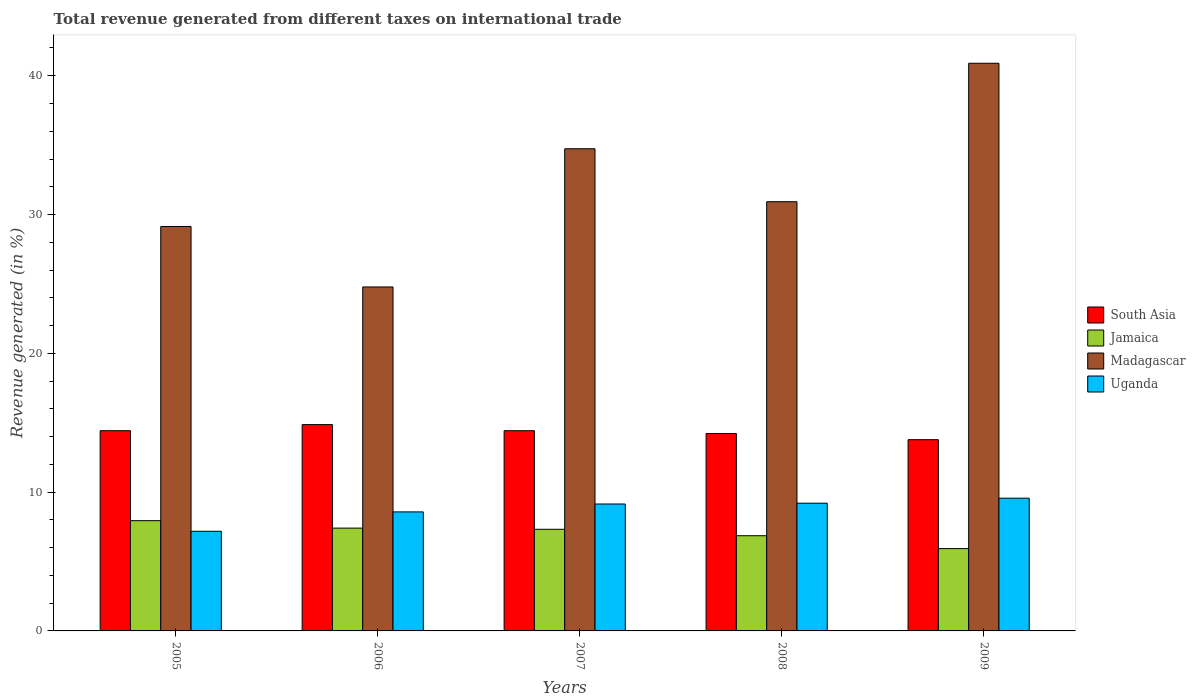How many different coloured bars are there?
Your answer should be very brief. 4. How many groups of bars are there?
Make the answer very short. 5. Are the number of bars on each tick of the X-axis equal?
Your answer should be compact. Yes. How many bars are there on the 2nd tick from the left?
Your response must be concise. 4. How many bars are there on the 4th tick from the right?
Your response must be concise. 4. What is the total revenue generated in Uganda in 2006?
Give a very brief answer. 8.58. Across all years, what is the maximum total revenue generated in South Asia?
Offer a very short reply. 14.86. Across all years, what is the minimum total revenue generated in Uganda?
Keep it short and to the point. 7.18. In which year was the total revenue generated in Uganda minimum?
Offer a terse response. 2005. What is the total total revenue generated in Madagascar in the graph?
Keep it short and to the point. 160.48. What is the difference between the total revenue generated in Madagascar in 2006 and that in 2008?
Your answer should be compact. -6.14. What is the difference between the total revenue generated in Jamaica in 2005 and the total revenue generated in Uganda in 2006?
Your answer should be very brief. -0.63. What is the average total revenue generated in Madagascar per year?
Offer a very short reply. 32.1. In the year 2008, what is the difference between the total revenue generated in Jamaica and total revenue generated in Uganda?
Make the answer very short. -2.34. In how many years, is the total revenue generated in Jamaica greater than 24 %?
Provide a short and direct response. 0. What is the ratio of the total revenue generated in Uganda in 2005 to that in 2006?
Make the answer very short. 0.84. Is the total revenue generated in Jamaica in 2005 less than that in 2009?
Provide a short and direct response. No. Is the difference between the total revenue generated in Jamaica in 2005 and 2008 greater than the difference between the total revenue generated in Uganda in 2005 and 2008?
Your answer should be very brief. Yes. What is the difference between the highest and the second highest total revenue generated in Uganda?
Give a very brief answer. 0.36. What is the difference between the highest and the lowest total revenue generated in South Asia?
Keep it short and to the point. 1.09. Is it the case that in every year, the sum of the total revenue generated in Madagascar and total revenue generated in Jamaica is greater than the sum of total revenue generated in Uganda and total revenue generated in South Asia?
Ensure brevity in your answer.  Yes. What does the 1st bar from the left in 2007 represents?
Provide a short and direct response. South Asia. What does the 2nd bar from the right in 2008 represents?
Give a very brief answer. Madagascar. Is it the case that in every year, the sum of the total revenue generated in South Asia and total revenue generated in Jamaica is greater than the total revenue generated in Madagascar?
Your answer should be very brief. No. Are the values on the major ticks of Y-axis written in scientific E-notation?
Make the answer very short. No. Does the graph contain any zero values?
Give a very brief answer. No. Does the graph contain grids?
Provide a short and direct response. No. How are the legend labels stacked?
Keep it short and to the point. Vertical. What is the title of the graph?
Ensure brevity in your answer.  Total revenue generated from different taxes on international trade. What is the label or title of the X-axis?
Keep it short and to the point. Years. What is the label or title of the Y-axis?
Offer a terse response. Revenue generated (in %). What is the Revenue generated (in %) in South Asia in 2005?
Give a very brief answer. 14.43. What is the Revenue generated (in %) in Jamaica in 2005?
Offer a very short reply. 7.94. What is the Revenue generated (in %) of Madagascar in 2005?
Make the answer very short. 29.14. What is the Revenue generated (in %) in Uganda in 2005?
Give a very brief answer. 7.18. What is the Revenue generated (in %) in South Asia in 2006?
Provide a short and direct response. 14.86. What is the Revenue generated (in %) in Jamaica in 2006?
Give a very brief answer. 7.41. What is the Revenue generated (in %) in Madagascar in 2006?
Keep it short and to the point. 24.78. What is the Revenue generated (in %) of Uganda in 2006?
Provide a short and direct response. 8.58. What is the Revenue generated (in %) of South Asia in 2007?
Provide a succinct answer. 14.42. What is the Revenue generated (in %) of Jamaica in 2007?
Provide a short and direct response. 7.32. What is the Revenue generated (in %) of Madagascar in 2007?
Give a very brief answer. 34.74. What is the Revenue generated (in %) in Uganda in 2007?
Keep it short and to the point. 9.14. What is the Revenue generated (in %) of South Asia in 2008?
Offer a very short reply. 14.22. What is the Revenue generated (in %) in Jamaica in 2008?
Provide a short and direct response. 6.86. What is the Revenue generated (in %) of Madagascar in 2008?
Make the answer very short. 30.92. What is the Revenue generated (in %) in Uganda in 2008?
Offer a very short reply. 9.2. What is the Revenue generated (in %) of South Asia in 2009?
Your answer should be very brief. 13.78. What is the Revenue generated (in %) of Jamaica in 2009?
Offer a very short reply. 5.93. What is the Revenue generated (in %) of Madagascar in 2009?
Provide a succinct answer. 40.9. What is the Revenue generated (in %) of Uganda in 2009?
Your answer should be very brief. 9.56. Across all years, what is the maximum Revenue generated (in %) in South Asia?
Make the answer very short. 14.86. Across all years, what is the maximum Revenue generated (in %) of Jamaica?
Give a very brief answer. 7.94. Across all years, what is the maximum Revenue generated (in %) of Madagascar?
Offer a terse response. 40.9. Across all years, what is the maximum Revenue generated (in %) of Uganda?
Provide a short and direct response. 9.56. Across all years, what is the minimum Revenue generated (in %) in South Asia?
Ensure brevity in your answer.  13.78. Across all years, what is the minimum Revenue generated (in %) of Jamaica?
Provide a short and direct response. 5.93. Across all years, what is the minimum Revenue generated (in %) in Madagascar?
Your answer should be very brief. 24.78. Across all years, what is the minimum Revenue generated (in %) of Uganda?
Your response must be concise. 7.18. What is the total Revenue generated (in %) of South Asia in the graph?
Your answer should be very brief. 71.72. What is the total Revenue generated (in %) in Jamaica in the graph?
Offer a very short reply. 35.46. What is the total Revenue generated (in %) of Madagascar in the graph?
Provide a succinct answer. 160.48. What is the total Revenue generated (in %) of Uganda in the graph?
Keep it short and to the point. 43.67. What is the difference between the Revenue generated (in %) in South Asia in 2005 and that in 2006?
Offer a very short reply. -0.44. What is the difference between the Revenue generated (in %) of Jamaica in 2005 and that in 2006?
Make the answer very short. 0.54. What is the difference between the Revenue generated (in %) of Madagascar in 2005 and that in 2006?
Offer a very short reply. 4.36. What is the difference between the Revenue generated (in %) in Uganda in 2005 and that in 2006?
Your response must be concise. -1.39. What is the difference between the Revenue generated (in %) in South Asia in 2005 and that in 2007?
Offer a terse response. 0. What is the difference between the Revenue generated (in %) of Jamaica in 2005 and that in 2007?
Your answer should be compact. 0.62. What is the difference between the Revenue generated (in %) in Madagascar in 2005 and that in 2007?
Your response must be concise. -5.6. What is the difference between the Revenue generated (in %) of Uganda in 2005 and that in 2007?
Make the answer very short. -1.96. What is the difference between the Revenue generated (in %) of South Asia in 2005 and that in 2008?
Offer a terse response. 0.2. What is the difference between the Revenue generated (in %) in Jamaica in 2005 and that in 2008?
Provide a short and direct response. 1.09. What is the difference between the Revenue generated (in %) of Madagascar in 2005 and that in 2008?
Your answer should be very brief. -1.79. What is the difference between the Revenue generated (in %) in Uganda in 2005 and that in 2008?
Your answer should be compact. -2.02. What is the difference between the Revenue generated (in %) of South Asia in 2005 and that in 2009?
Your response must be concise. 0.65. What is the difference between the Revenue generated (in %) of Jamaica in 2005 and that in 2009?
Your response must be concise. 2.01. What is the difference between the Revenue generated (in %) of Madagascar in 2005 and that in 2009?
Ensure brevity in your answer.  -11.76. What is the difference between the Revenue generated (in %) of Uganda in 2005 and that in 2009?
Provide a short and direct response. -2.38. What is the difference between the Revenue generated (in %) of South Asia in 2006 and that in 2007?
Offer a very short reply. 0.44. What is the difference between the Revenue generated (in %) of Jamaica in 2006 and that in 2007?
Ensure brevity in your answer.  0.08. What is the difference between the Revenue generated (in %) in Madagascar in 2006 and that in 2007?
Give a very brief answer. -9.96. What is the difference between the Revenue generated (in %) in Uganda in 2006 and that in 2007?
Provide a succinct answer. -0.57. What is the difference between the Revenue generated (in %) in South Asia in 2006 and that in 2008?
Keep it short and to the point. 0.64. What is the difference between the Revenue generated (in %) in Jamaica in 2006 and that in 2008?
Your answer should be compact. 0.55. What is the difference between the Revenue generated (in %) in Madagascar in 2006 and that in 2008?
Ensure brevity in your answer.  -6.14. What is the difference between the Revenue generated (in %) of Uganda in 2006 and that in 2008?
Offer a terse response. -0.63. What is the difference between the Revenue generated (in %) of South Asia in 2006 and that in 2009?
Make the answer very short. 1.09. What is the difference between the Revenue generated (in %) of Jamaica in 2006 and that in 2009?
Give a very brief answer. 1.48. What is the difference between the Revenue generated (in %) of Madagascar in 2006 and that in 2009?
Ensure brevity in your answer.  -16.12. What is the difference between the Revenue generated (in %) of Uganda in 2006 and that in 2009?
Offer a terse response. -0.99. What is the difference between the Revenue generated (in %) of South Asia in 2007 and that in 2008?
Provide a succinct answer. 0.2. What is the difference between the Revenue generated (in %) of Jamaica in 2007 and that in 2008?
Your answer should be compact. 0.46. What is the difference between the Revenue generated (in %) in Madagascar in 2007 and that in 2008?
Your response must be concise. 3.82. What is the difference between the Revenue generated (in %) of Uganda in 2007 and that in 2008?
Your answer should be very brief. -0.06. What is the difference between the Revenue generated (in %) in South Asia in 2007 and that in 2009?
Your answer should be compact. 0.65. What is the difference between the Revenue generated (in %) in Jamaica in 2007 and that in 2009?
Offer a terse response. 1.39. What is the difference between the Revenue generated (in %) in Madagascar in 2007 and that in 2009?
Keep it short and to the point. -6.16. What is the difference between the Revenue generated (in %) in Uganda in 2007 and that in 2009?
Your answer should be compact. -0.42. What is the difference between the Revenue generated (in %) in South Asia in 2008 and that in 2009?
Provide a short and direct response. 0.45. What is the difference between the Revenue generated (in %) in Jamaica in 2008 and that in 2009?
Provide a short and direct response. 0.93. What is the difference between the Revenue generated (in %) in Madagascar in 2008 and that in 2009?
Your response must be concise. -9.98. What is the difference between the Revenue generated (in %) of Uganda in 2008 and that in 2009?
Make the answer very short. -0.36. What is the difference between the Revenue generated (in %) in South Asia in 2005 and the Revenue generated (in %) in Jamaica in 2006?
Offer a very short reply. 7.02. What is the difference between the Revenue generated (in %) of South Asia in 2005 and the Revenue generated (in %) of Madagascar in 2006?
Give a very brief answer. -10.36. What is the difference between the Revenue generated (in %) of South Asia in 2005 and the Revenue generated (in %) of Uganda in 2006?
Keep it short and to the point. 5.85. What is the difference between the Revenue generated (in %) of Jamaica in 2005 and the Revenue generated (in %) of Madagascar in 2006?
Offer a very short reply. -16.84. What is the difference between the Revenue generated (in %) in Jamaica in 2005 and the Revenue generated (in %) in Uganda in 2006?
Ensure brevity in your answer.  -0.63. What is the difference between the Revenue generated (in %) in Madagascar in 2005 and the Revenue generated (in %) in Uganda in 2006?
Offer a very short reply. 20.56. What is the difference between the Revenue generated (in %) of South Asia in 2005 and the Revenue generated (in %) of Jamaica in 2007?
Ensure brevity in your answer.  7.1. What is the difference between the Revenue generated (in %) of South Asia in 2005 and the Revenue generated (in %) of Madagascar in 2007?
Your answer should be very brief. -20.31. What is the difference between the Revenue generated (in %) in South Asia in 2005 and the Revenue generated (in %) in Uganda in 2007?
Make the answer very short. 5.28. What is the difference between the Revenue generated (in %) of Jamaica in 2005 and the Revenue generated (in %) of Madagascar in 2007?
Ensure brevity in your answer.  -26.8. What is the difference between the Revenue generated (in %) of Jamaica in 2005 and the Revenue generated (in %) of Uganda in 2007?
Your response must be concise. -1.2. What is the difference between the Revenue generated (in %) of Madagascar in 2005 and the Revenue generated (in %) of Uganda in 2007?
Make the answer very short. 19.99. What is the difference between the Revenue generated (in %) of South Asia in 2005 and the Revenue generated (in %) of Jamaica in 2008?
Make the answer very short. 7.57. What is the difference between the Revenue generated (in %) of South Asia in 2005 and the Revenue generated (in %) of Madagascar in 2008?
Give a very brief answer. -16.5. What is the difference between the Revenue generated (in %) in South Asia in 2005 and the Revenue generated (in %) in Uganda in 2008?
Ensure brevity in your answer.  5.22. What is the difference between the Revenue generated (in %) of Jamaica in 2005 and the Revenue generated (in %) of Madagascar in 2008?
Offer a very short reply. -22.98. What is the difference between the Revenue generated (in %) of Jamaica in 2005 and the Revenue generated (in %) of Uganda in 2008?
Ensure brevity in your answer.  -1.26. What is the difference between the Revenue generated (in %) in Madagascar in 2005 and the Revenue generated (in %) in Uganda in 2008?
Ensure brevity in your answer.  19.94. What is the difference between the Revenue generated (in %) of South Asia in 2005 and the Revenue generated (in %) of Jamaica in 2009?
Ensure brevity in your answer.  8.49. What is the difference between the Revenue generated (in %) in South Asia in 2005 and the Revenue generated (in %) in Madagascar in 2009?
Your answer should be compact. -26.47. What is the difference between the Revenue generated (in %) of South Asia in 2005 and the Revenue generated (in %) of Uganda in 2009?
Your answer should be compact. 4.86. What is the difference between the Revenue generated (in %) in Jamaica in 2005 and the Revenue generated (in %) in Madagascar in 2009?
Provide a succinct answer. -32.96. What is the difference between the Revenue generated (in %) of Jamaica in 2005 and the Revenue generated (in %) of Uganda in 2009?
Give a very brief answer. -1.62. What is the difference between the Revenue generated (in %) of Madagascar in 2005 and the Revenue generated (in %) of Uganda in 2009?
Keep it short and to the point. 19.57. What is the difference between the Revenue generated (in %) of South Asia in 2006 and the Revenue generated (in %) of Jamaica in 2007?
Provide a succinct answer. 7.54. What is the difference between the Revenue generated (in %) of South Asia in 2006 and the Revenue generated (in %) of Madagascar in 2007?
Provide a short and direct response. -19.87. What is the difference between the Revenue generated (in %) of South Asia in 2006 and the Revenue generated (in %) of Uganda in 2007?
Your answer should be compact. 5.72. What is the difference between the Revenue generated (in %) in Jamaica in 2006 and the Revenue generated (in %) in Madagascar in 2007?
Make the answer very short. -27.33. What is the difference between the Revenue generated (in %) of Jamaica in 2006 and the Revenue generated (in %) of Uganda in 2007?
Keep it short and to the point. -1.74. What is the difference between the Revenue generated (in %) of Madagascar in 2006 and the Revenue generated (in %) of Uganda in 2007?
Keep it short and to the point. 15.64. What is the difference between the Revenue generated (in %) of South Asia in 2006 and the Revenue generated (in %) of Jamaica in 2008?
Provide a succinct answer. 8.01. What is the difference between the Revenue generated (in %) of South Asia in 2006 and the Revenue generated (in %) of Madagascar in 2008?
Your response must be concise. -16.06. What is the difference between the Revenue generated (in %) in South Asia in 2006 and the Revenue generated (in %) in Uganda in 2008?
Your answer should be very brief. 5.66. What is the difference between the Revenue generated (in %) in Jamaica in 2006 and the Revenue generated (in %) in Madagascar in 2008?
Your answer should be very brief. -23.52. What is the difference between the Revenue generated (in %) of Jamaica in 2006 and the Revenue generated (in %) of Uganda in 2008?
Provide a short and direct response. -1.8. What is the difference between the Revenue generated (in %) of Madagascar in 2006 and the Revenue generated (in %) of Uganda in 2008?
Provide a succinct answer. 15.58. What is the difference between the Revenue generated (in %) of South Asia in 2006 and the Revenue generated (in %) of Jamaica in 2009?
Provide a succinct answer. 8.93. What is the difference between the Revenue generated (in %) of South Asia in 2006 and the Revenue generated (in %) of Madagascar in 2009?
Give a very brief answer. -26.03. What is the difference between the Revenue generated (in %) in South Asia in 2006 and the Revenue generated (in %) in Uganda in 2009?
Provide a succinct answer. 5.3. What is the difference between the Revenue generated (in %) in Jamaica in 2006 and the Revenue generated (in %) in Madagascar in 2009?
Keep it short and to the point. -33.49. What is the difference between the Revenue generated (in %) in Jamaica in 2006 and the Revenue generated (in %) in Uganda in 2009?
Provide a succinct answer. -2.16. What is the difference between the Revenue generated (in %) in Madagascar in 2006 and the Revenue generated (in %) in Uganda in 2009?
Ensure brevity in your answer.  15.22. What is the difference between the Revenue generated (in %) in South Asia in 2007 and the Revenue generated (in %) in Jamaica in 2008?
Your answer should be very brief. 7.57. What is the difference between the Revenue generated (in %) of South Asia in 2007 and the Revenue generated (in %) of Madagascar in 2008?
Your answer should be very brief. -16.5. What is the difference between the Revenue generated (in %) of South Asia in 2007 and the Revenue generated (in %) of Uganda in 2008?
Your answer should be compact. 5.22. What is the difference between the Revenue generated (in %) of Jamaica in 2007 and the Revenue generated (in %) of Madagascar in 2008?
Ensure brevity in your answer.  -23.6. What is the difference between the Revenue generated (in %) of Jamaica in 2007 and the Revenue generated (in %) of Uganda in 2008?
Ensure brevity in your answer.  -1.88. What is the difference between the Revenue generated (in %) in Madagascar in 2007 and the Revenue generated (in %) in Uganda in 2008?
Offer a very short reply. 25.54. What is the difference between the Revenue generated (in %) of South Asia in 2007 and the Revenue generated (in %) of Jamaica in 2009?
Provide a short and direct response. 8.49. What is the difference between the Revenue generated (in %) in South Asia in 2007 and the Revenue generated (in %) in Madagascar in 2009?
Offer a very short reply. -26.48. What is the difference between the Revenue generated (in %) in South Asia in 2007 and the Revenue generated (in %) in Uganda in 2009?
Keep it short and to the point. 4.86. What is the difference between the Revenue generated (in %) of Jamaica in 2007 and the Revenue generated (in %) of Madagascar in 2009?
Offer a very short reply. -33.58. What is the difference between the Revenue generated (in %) of Jamaica in 2007 and the Revenue generated (in %) of Uganda in 2009?
Ensure brevity in your answer.  -2.24. What is the difference between the Revenue generated (in %) of Madagascar in 2007 and the Revenue generated (in %) of Uganda in 2009?
Provide a short and direct response. 25.18. What is the difference between the Revenue generated (in %) in South Asia in 2008 and the Revenue generated (in %) in Jamaica in 2009?
Offer a terse response. 8.29. What is the difference between the Revenue generated (in %) of South Asia in 2008 and the Revenue generated (in %) of Madagascar in 2009?
Provide a succinct answer. -26.68. What is the difference between the Revenue generated (in %) of South Asia in 2008 and the Revenue generated (in %) of Uganda in 2009?
Your answer should be very brief. 4.66. What is the difference between the Revenue generated (in %) in Jamaica in 2008 and the Revenue generated (in %) in Madagascar in 2009?
Keep it short and to the point. -34.04. What is the difference between the Revenue generated (in %) of Jamaica in 2008 and the Revenue generated (in %) of Uganda in 2009?
Provide a short and direct response. -2.71. What is the difference between the Revenue generated (in %) of Madagascar in 2008 and the Revenue generated (in %) of Uganda in 2009?
Make the answer very short. 21.36. What is the average Revenue generated (in %) in South Asia per year?
Your answer should be very brief. 14.34. What is the average Revenue generated (in %) in Jamaica per year?
Provide a succinct answer. 7.09. What is the average Revenue generated (in %) in Madagascar per year?
Keep it short and to the point. 32.1. What is the average Revenue generated (in %) in Uganda per year?
Make the answer very short. 8.73. In the year 2005, what is the difference between the Revenue generated (in %) of South Asia and Revenue generated (in %) of Jamaica?
Your answer should be very brief. 6.48. In the year 2005, what is the difference between the Revenue generated (in %) in South Asia and Revenue generated (in %) in Madagascar?
Offer a very short reply. -14.71. In the year 2005, what is the difference between the Revenue generated (in %) in South Asia and Revenue generated (in %) in Uganda?
Offer a very short reply. 7.24. In the year 2005, what is the difference between the Revenue generated (in %) of Jamaica and Revenue generated (in %) of Madagascar?
Offer a terse response. -21.19. In the year 2005, what is the difference between the Revenue generated (in %) in Jamaica and Revenue generated (in %) in Uganda?
Your answer should be very brief. 0.76. In the year 2005, what is the difference between the Revenue generated (in %) in Madagascar and Revenue generated (in %) in Uganda?
Your response must be concise. 21.96. In the year 2006, what is the difference between the Revenue generated (in %) of South Asia and Revenue generated (in %) of Jamaica?
Provide a short and direct response. 7.46. In the year 2006, what is the difference between the Revenue generated (in %) in South Asia and Revenue generated (in %) in Madagascar?
Provide a short and direct response. -9.92. In the year 2006, what is the difference between the Revenue generated (in %) in South Asia and Revenue generated (in %) in Uganda?
Your answer should be very brief. 6.29. In the year 2006, what is the difference between the Revenue generated (in %) in Jamaica and Revenue generated (in %) in Madagascar?
Your response must be concise. -17.38. In the year 2006, what is the difference between the Revenue generated (in %) of Jamaica and Revenue generated (in %) of Uganda?
Provide a short and direct response. -1.17. In the year 2006, what is the difference between the Revenue generated (in %) of Madagascar and Revenue generated (in %) of Uganda?
Give a very brief answer. 16.21. In the year 2007, what is the difference between the Revenue generated (in %) of South Asia and Revenue generated (in %) of Jamaica?
Offer a very short reply. 7.1. In the year 2007, what is the difference between the Revenue generated (in %) of South Asia and Revenue generated (in %) of Madagascar?
Your answer should be compact. -20.31. In the year 2007, what is the difference between the Revenue generated (in %) of South Asia and Revenue generated (in %) of Uganda?
Give a very brief answer. 5.28. In the year 2007, what is the difference between the Revenue generated (in %) in Jamaica and Revenue generated (in %) in Madagascar?
Your response must be concise. -27.42. In the year 2007, what is the difference between the Revenue generated (in %) of Jamaica and Revenue generated (in %) of Uganda?
Make the answer very short. -1.82. In the year 2007, what is the difference between the Revenue generated (in %) of Madagascar and Revenue generated (in %) of Uganda?
Ensure brevity in your answer.  25.6. In the year 2008, what is the difference between the Revenue generated (in %) in South Asia and Revenue generated (in %) in Jamaica?
Offer a very short reply. 7.37. In the year 2008, what is the difference between the Revenue generated (in %) in South Asia and Revenue generated (in %) in Madagascar?
Make the answer very short. -16.7. In the year 2008, what is the difference between the Revenue generated (in %) in South Asia and Revenue generated (in %) in Uganda?
Your answer should be compact. 5.02. In the year 2008, what is the difference between the Revenue generated (in %) of Jamaica and Revenue generated (in %) of Madagascar?
Offer a very short reply. -24.07. In the year 2008, what is the difference between the Revenue generated (in %) in Jamaica and Revenue generated (in %) in Uganda?
Offer a terse response. -2.34. In the year 2008, what is the difference between the Revenue generated (in %) of Madagascar and Revenue generated (in %) of Uganda?
Your answer should be very brief. 21.72. In the year 2009, what is the difference between the Revenue generated (in %) of South Asia and Revenue generated (in %) of Jamaica?
Provide a succinct answer. 7.85. In the year 2009, what is the difference between the Revenue generated (in %) in South Asia and Revenue generated (in %) in Madagascar?
Your answer should be very brief. -27.12. In the year 2009, what is the difference between the Revenue generated (in %) in South Asia and Revenue generated (in %) in Uganda?
Your answer should be very brief. 4.22. In the year 2009, what is the difference between the Revenue generated (in %) of Jamaica and Revenue generated (in %) of Madagascar?
Your answer should be very brief. -34.97. In the year 2009, what is the difference between the Revenue generated (in %) of Jamaica and Revenue generated (in %) of Uganda?
Your answer should be compact. -3.63. In the year 2009, what is the difference between the Revenue generated (in %) in Madagascar and Revenue generated (in %) in Uganda?
Your answer should be compact. 31.34. What is the ratio of the Revenue generated (in %) in South Asia in 2005 to that in 2006?
Your answer should be very brief. 0.97. What is the ratio of the Revenue generated (in %) of Jamaica in 2005 to that in 2006?
Make the answer very short. 1.07. What is the ratio of the Revenue generated (in %) of Madagascar in 2005 to that in 2006?
Offer a very short reply. 1.18. What is the ratio of the Revenue generated (in %) in Uganda in 2005 to that in 2006?
Offer a very short reply. 0.84. What is the ratio of the Revenue generated (in %) of Jamaica in 2005 to that in 2007?
Provide a short and direct response. 1.08. What is the ratio of the Revenue generated (in %) in Madagascar in 2005 to that in 2007?
Provide a succinct answer. 0.84. What is the ratio of the Revenue generated (in %) of Uganda in 2005 to that in 2007?
Ensure brevity in your answer.  0.79. What is the ratio of the Revenue generated (in %) of South Asia in 2005 to that in 2008?
Keep it short and to the point. 1.01. What is the ratio of the Revenue generated (in %) of Jamaica in 2005 to that in 2008?
Your answer should be very brief. 1.16. What is the ratio of the Revenue generated (in %) in Madagascar in 2005 to that in 2008?
Your answer should be compact. 0.94. What is the ratio of the Revenue generated (in %) in Uganda in 2005 to that in 2008?
Ensure brevity in your answer.  0.78. What is the ratio of the Revenue generated (in %) in South Asia in 2005 to that in 2009?
Keep it short and to the point. 1.05. What is the ratio of the Revenue generated (in %) in Jamaica in 2005 to that in 2009?
Your response must be concise. 1.34. What is the ratio of the Revenue generated (in %) of Madagascar in 2005 to that in 2009?
Provide a short and direct response. 0.71. What is the ratio of the Revenue generated (in %) of Uganda in 2005 to that in 2009?
Provide a succinct answer. 0.75. What is the ratio of the Revenue generated (in %) of South Asia in 2006 to that in 2007?
Offer a terse response. 1.03. What is the ratio of the Revenue generated (in %) of Jamaica in 2006 to that in 2007?
Your answer should be compact. 1.01. What is the ratio of the Revenue generated (in %) of Madagascar in 2006 to that in 2007?
Your answer should be compact. 0.71. What is the ratio of the Revenue generated (in %) in Uganda in 2006 to that in 2007?
Your answer should be compact. 0.94. What is the ratio of the Revenue generated (in %) in South Asia in 2006 to that in 2008?
Your response must be concise. 1.04. What is the ratio of the Revenue generated (in %) in Madagascar in 2006 to that in 2008?
Keep it short and to the point. 0.8. What is the ratio of the Revenue generated (in %) in Uganda in 2006 to that in 2008?
Your answer should be compact. 0.93. What is the ratio of the Revenue generated (in %) of South Asia in 2006 to that in 2009?
Make the answer very short. 1.08. What is the ratio of the Revenue generated (in %) in Jamaica in 2006 to that in 2009?
Your response must be concise. 1.25. What is the ratio of the Revenue generated (in %) in Madagascar in 2006 to that in 2009?
Your answer should be compact. 0.61. What is the ratio of the Revenue generated (in %) in Uganda in 2006 to that in 2009?
Keep it short and to the point. 0.9. What is the ratio of the Revenue generated (in %) in South Asia in 2007 to that in 2008?
Make the answer very short. 1.01. What is the ratio of the Revenue generated (in %) of Jamaica in 2007 to that in 2008?
Your answer should be compact. 1.07. What is the ratio of the Revenue generated (in %) in Madagascar in 2007 to that in 2008?
Make the answer very short. 1.12. What is the ratio of the Revenue generated (in %) in South Asia in 2007 to that in 2009?
Offer a terse response. 1.05. What is the ratio of the Revenue generated (in %) of Jamaica in 2007 to that in 2009?
Keep it short and to the point. 1.23. What is the ratio of the Revenue generated (in %) of Madagascar in 2007 to that in 2009?
Keep it short and to the point. 0.85. What is the ratio of the Revenue generated (in %) in Uganda in 2007 to that in 2009?
Ensure brevity in your answer.  0.96. What is the ratio of the Revenue generated (in %) in South Asia in 2008 to that in 2009?
Keep it short and to the point. 1.03. What is the ratio of the Revenue generated (in %) in Jamaica in 2008 to that in 2009?
Give a very brief answer. 1.16. What is the ratio of the Revenue generated (in %) of Madagascar in 2008 to that in 2009?
Provide a short and direct response. 0.76. What is the ratio of the Revenue generated (in %) of Uganda in 2008 to that in 2009?
Your answer should be very brief. 0.96. What is the difference between the highest and the second highest Revenue generated (in %) in South Asia?
Keep it short and to the point. 0.44. What is the difference between the highest and the second highest Revenue generated (in %) in Jamaica?
Ensure brevity in your answer.  0.54. What is the difference between the highest and the second highest Revenue generated (in %) of Madagascar?
Ensure brevity in your answer.  6.16. What is the difference between the highest and the second highest Revenue generated (in %) of Uganda?
Make the answer very short. 0.36. What is the difference between the highest and the lowest Revenue generated (in %) of South Asia?
Keep it short and to the point. 1.09. What is the difference between the highest and the lowest Revenue generated (in %) of Jamaica?
Your response must be concise. 2.01. What is the difference between the highest and the lowest Revenue generated (in %) in Madagascar?
Provide a succinct answer. 16.12. What is the difference between the highest and the lowest Revenue generated (in %) of Uganda?
Provide a succinct answer. 2.38. 